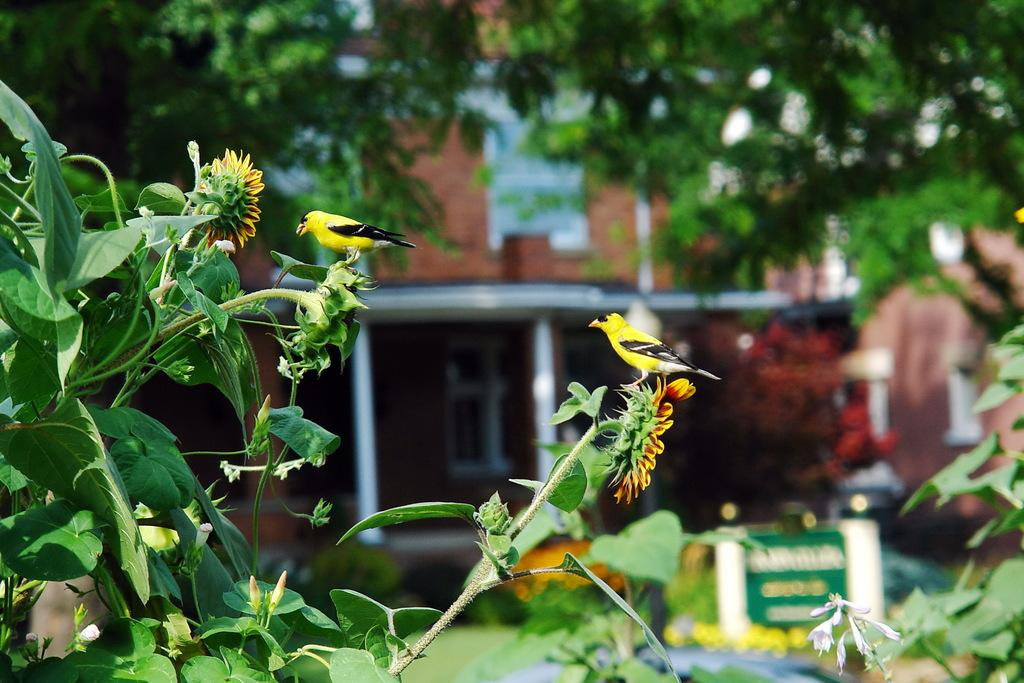What is on the plant in the image? There is a bird on a plant in the image. What can be seen on the plant besides the bird? The plant has flowers. How would you describe the background of the image? The background is blurry. What structures are visible in the background? There is a building with windows and a tree in the background. What type of underwear is the bird wearing in the image? Birds do not wear underwear, so this question cannot be answered. How does the bird's presence affect the nerves of the plant in the image? The image does not provide information about the bird's effect on the plant's nerves, as plants do not have nerves like animals do. 